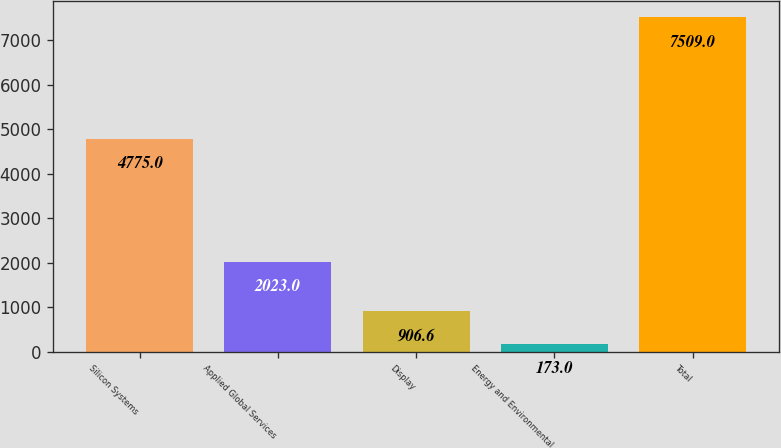Convert chart to OTSL. <chart><loc_0><loc_0><loc_500><loc_500><bar_chart><fcel>Silicon Systems<fcel>Applied Global Services<fcel>Display<fcel>Energy and Environmental<fcel>Total<nl><fcel>4775<fcel>2023<fcel>906.6<fcel>173<fcel>7509<nl></chart> 